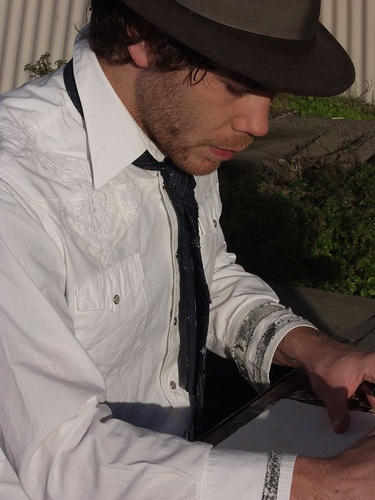Describe the objects in this image and their specific colors. I can see people in darkgray, black, and maroon tones and tie in darkgray, black, and gray tones in this image. 